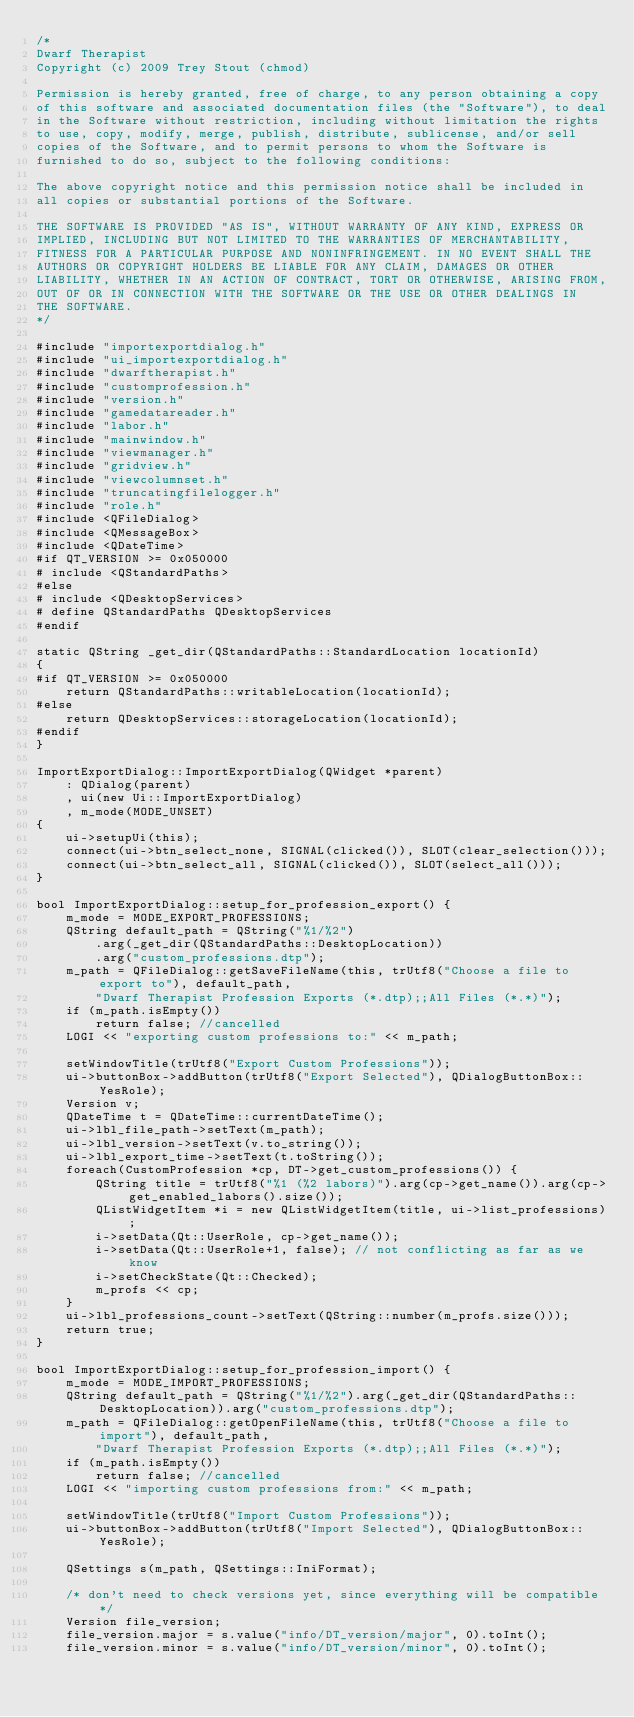Convert code to text. <code><loc_0><loc_0><loc_500><loc_500><_C++_>/*
Dwarf Therapist
Copyright (c) 2009 Trey Stout (chmod)

Permission is hereby granted, free of charge, to any person obtaining a copy
of this software and associated documentation files (the "Software"), to deal
in the Software without restriction, including without limitation the rights
to use, copy, modify, merge, publish, distribute, sublicense, and/or sell
copies of the Software, and to permit persons to whom the Software is
furnished to do so, subject to the following conditions:

The above copyright notice and this permission notice shall be included in
all copies or substantial portions of the Software.

THE SOFTWARE IS PROVIDED "AS IS", WITHOUT WARRANTY OF ANY KIND, EXPRESS OR
IMPLIED, INCLUDING BUT NOT LIMITED TO THE WARRANTIES OF MERCHANTABILITY,
FITNESS FOR A PARTICULAR PURPOSE AND NONINFRINGEMENT. IN NO EVENT SHALL THE
AUTHORS OR COPYRIGHT HOLDERS BE LIABLE FOR ANY CLAIM, DAMAGES OR OTHER
LIABILITY, WHETHER IN AN ACTION OF CONTRACT, TORT OR OTHERWISE, ARISING FROM,
OUT OF OR IN CONNECTION WITH THE SOFTWARE OR THE USE OR OTHER DEALINGS IN
THE SOFTWARE.
*/

#include "importexportdialog.h"
#include "ui_importexportdialog.h"
#include "dwarftherapist.h"
#include "customprofession.h"
#include "version.h"
#include "gamedatareader.h"
#include "labor.h"
#include "mainwindow.h"
#include "viewmanager.h"
#include "gridview.h"
#include "viewcolumnset.h"
#include "truncatingfilelogger.h"
#include "role.h"
#include <QFileDialog>
#include <QMessageBox>
#include <QDateTime>
#if QT_VERSION >= 0x050000
# include <QStandardPaths>
#else
# include <QDesktopServices>
# define QStandardPaths QDesktopServices
#endif

static QString _get_dir(QStandardPaths::StandardLocation locationId)
{
#if QT_VERSION >= 0x050000
    return QStandardPaths::writableLocation(locationId);
#else
    return QDesktopServices::storageLocation(locationId);
#endif
}

ImportExportDialog::ImportExportDialog(QWidget *parent)
    : QDialog(parent)
    , ui(new Ui::ImportExportDialog)
    , m_mode(MODE_UNSET)
{
    ui->setupUi(this);
    connect(ui->btn_select_none, SIGNAL(clicked()), SLOT(clear_selection()));
    connect(ui->btn_select_all, SIGNAL(clicked()), SLOT(select_all()));
}

bool ImportExportDialog::setup_for_profession_export() {
    m_mode = MODE_EXPORT_PROFESSIONS;
    QString default_path = QString("%1/%2")
        .arg(_get_dir(QStandardPaths::DesktopLocation))
        .arg("custom_professions.dtp");
    m_path = QFileDialog::getSaveFileName(this, trUtf8("Choose a file to export to"),	default_path,
        "Dwarf Therapist Profession Exports (*.dtp);;All Files (*.*)");
    if (m_path.isEmpty())
        return false; //cancelled
    LOGI << "exporting custom professions to:" << m_path;

    setWindowTitle(trUtf8("Export Custom Professions"));
    ui->buttonBox->addButton(trUtf8("Export Selected"), QDialogButtonBox::YesRole);
    Version v;
    QDateTime t = QDateTime::currentDateTime();
    ui->lbl_file_path->setText(m_path);
    ui->lbl_version->setText(v.to_string());
    ui->lbl_export_time->setText(t.toString());
    foreach(CustomProfession *cp, DT->get_custom_professions()) {
        QString title = trUtf8("%1 (%2 labors)").arg(cp->get_name()).arg(cp->get_enabled_labors().size());
        QListWidgetItem *i = new QListWidgetItem(title, ui->list_professions);
        i->setData(Qt::UserRole, cp->get_name());
        i->setData(Qt::UserRole+1, false); // not conflicting as far as we know
        i->setCheckState(Qt::Checked);
        m_profs << cp;
    }
    ui->lbl_professions_count->setText(QString::number(m_profs.size()));
    return true;
}

bool ImportExportDialog::setup_for_profession_import() {
    m_mode = MODE_IMPORT_PROFESSIONS;
    QString default_path = QString("%1/%2").arg(_get_dir(QStandardPaths::DesktopLocation)).arg("custom_professions.dtp");
    m_path = QFileDialog::getOpenFileName(this, trUtf8("Choose a file to import"), default_path,
        "Dwarf Therapist Profession Exports (*.dtp);;All Files (*.*)");
    if (m_path.isEmpty())
        return false; //cancelled
    LOGI << "importing custom professions from:" << m_path;

    setWindowTitle(trUtf8("Import Custom Professions"));
    ui->buttonBox->addButton(trUtf8("Import Selected"), QDialogButtonBox::YesRole);

    QSettings s(m_path, QSettings::IniFormat);

    /* don't need to check versions yet, since everything will be compatible */
    Version file_version;
    file_version.major = s.value("info/DT_version/major", 0).toInt();
    file_version.minor = s.value("info/DT_version/minor", 0).toInt();</code> 